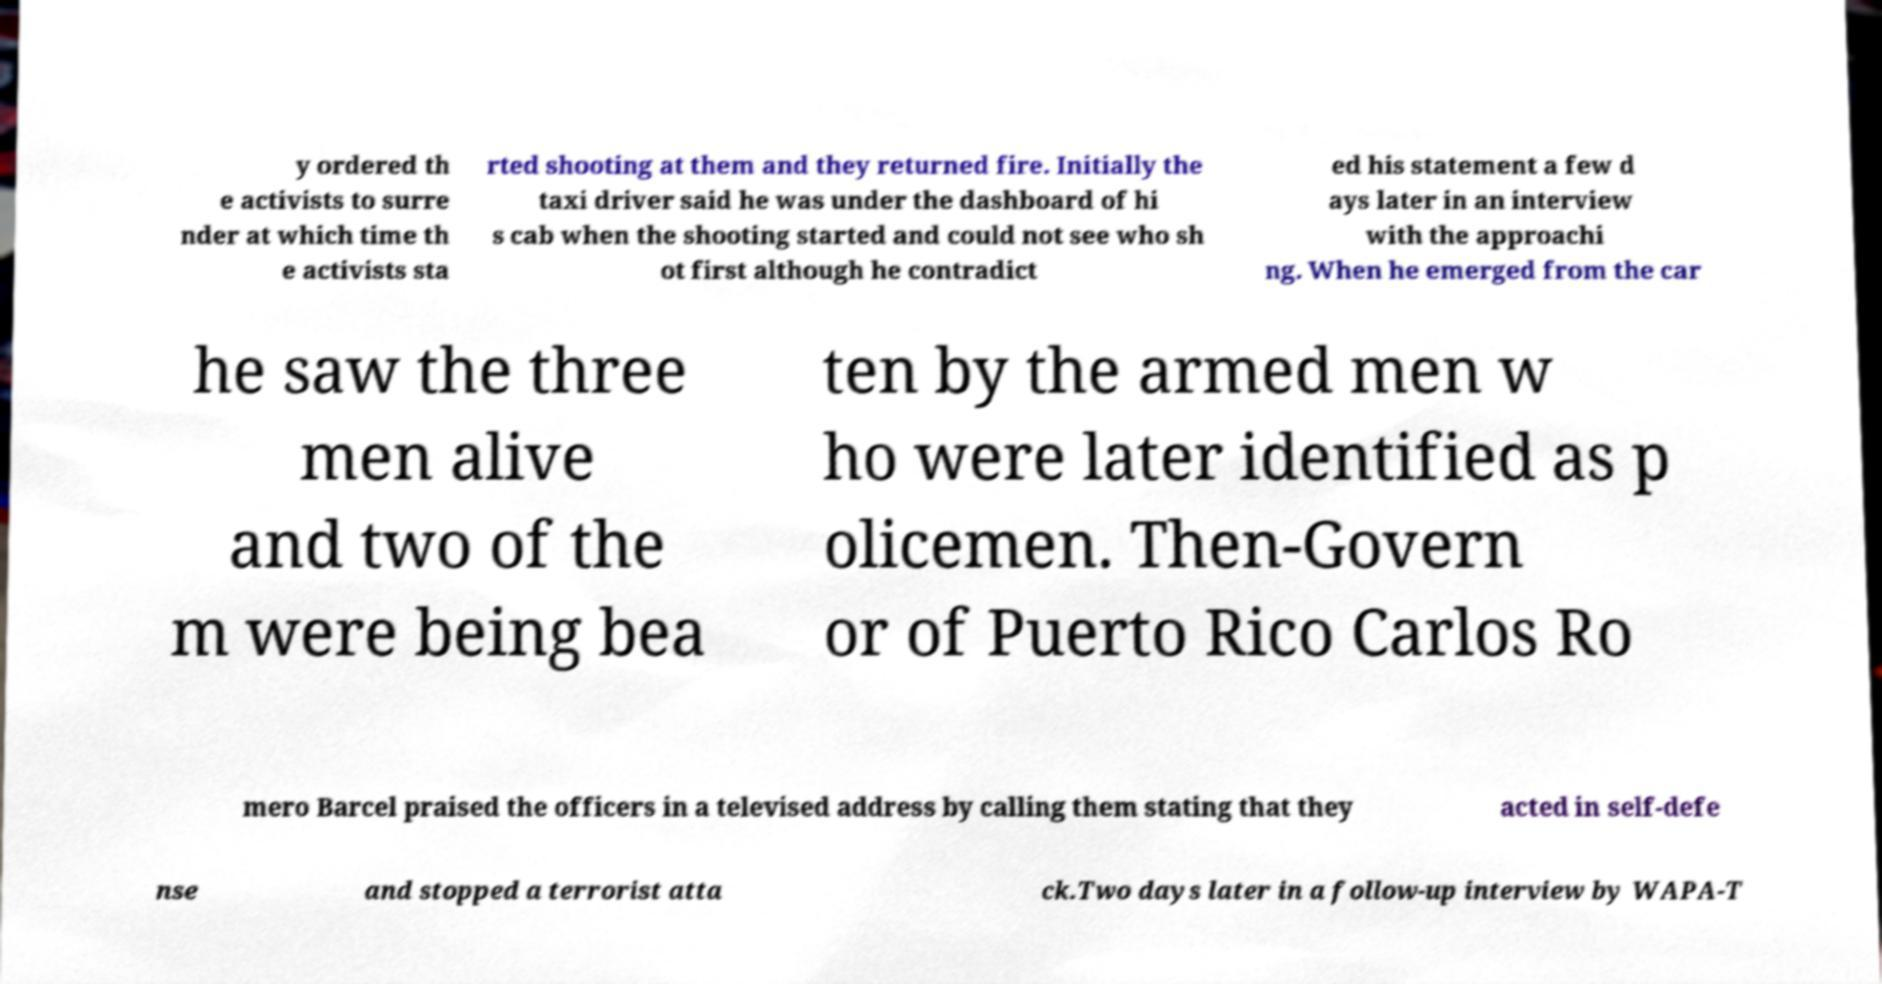Please read and relay the text visible in this image. What does it say? y ordered th e activists to surre nder at which time th e activists sta rted shooting at them and they returned fire. Initially the taxi driver said he was under the dashboard of hi s cab when the shooting started and could not see who sh ot first although he contradict ed his statement a few d ays later in an interview with the approachi ng. When he emerged from the car he saw the three men alive and two of the m were being bea ten by the armed men w ho were later identified as p olicemen. Then-Govern or of Puerto Rico Carlos Ro mero Barcel praised the officers in a televised address by calling them stating that they acted in self-defe nse and stopped a terrorist atta ck.Two days later in a follow-up interview by WAPA-T 